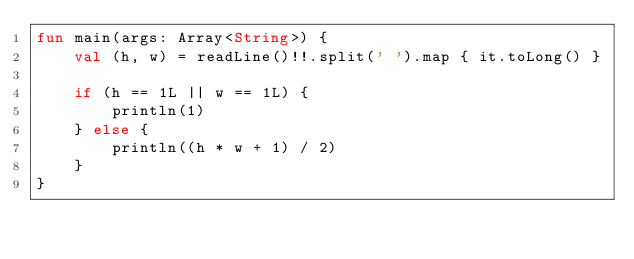Convert code to text. <code><loc_0><loc_0><loc_500><loc_500><_Kotlin_>fun main(args: Array<String>) {
    val (h, w) = readLine()!!.split(' ').map { it.toLong() }

    if (h == 1L || w == 1L) {
        println(1)
    } else {
        println((h * w + 1) / 2)
    }
}
</code> 